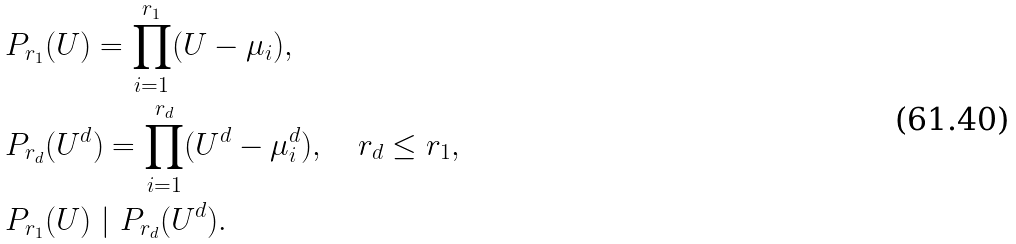<formula> <loc_0><loc_0><loc_500><loc_500>& P _ { r _ { 1 } } ( U ) = \prod _ { i = 1 } ^ { r _ { 1 } } ( U - \mu _ { i } ) , \\ & P _ { r _ { d } } ( U ^ { d } ) = \prod _ { i = 1 } ^ { r _ { d } } ( U ^ { d } - \mu _ { i } ^ { d } ) , \quad r _ { d } \leq r _ { 1 } , \\ & P _ { r _ { 1 } } ( U ) \ | \ P _ { r _ { d } } ( U ^ { d } ) .</formula> 